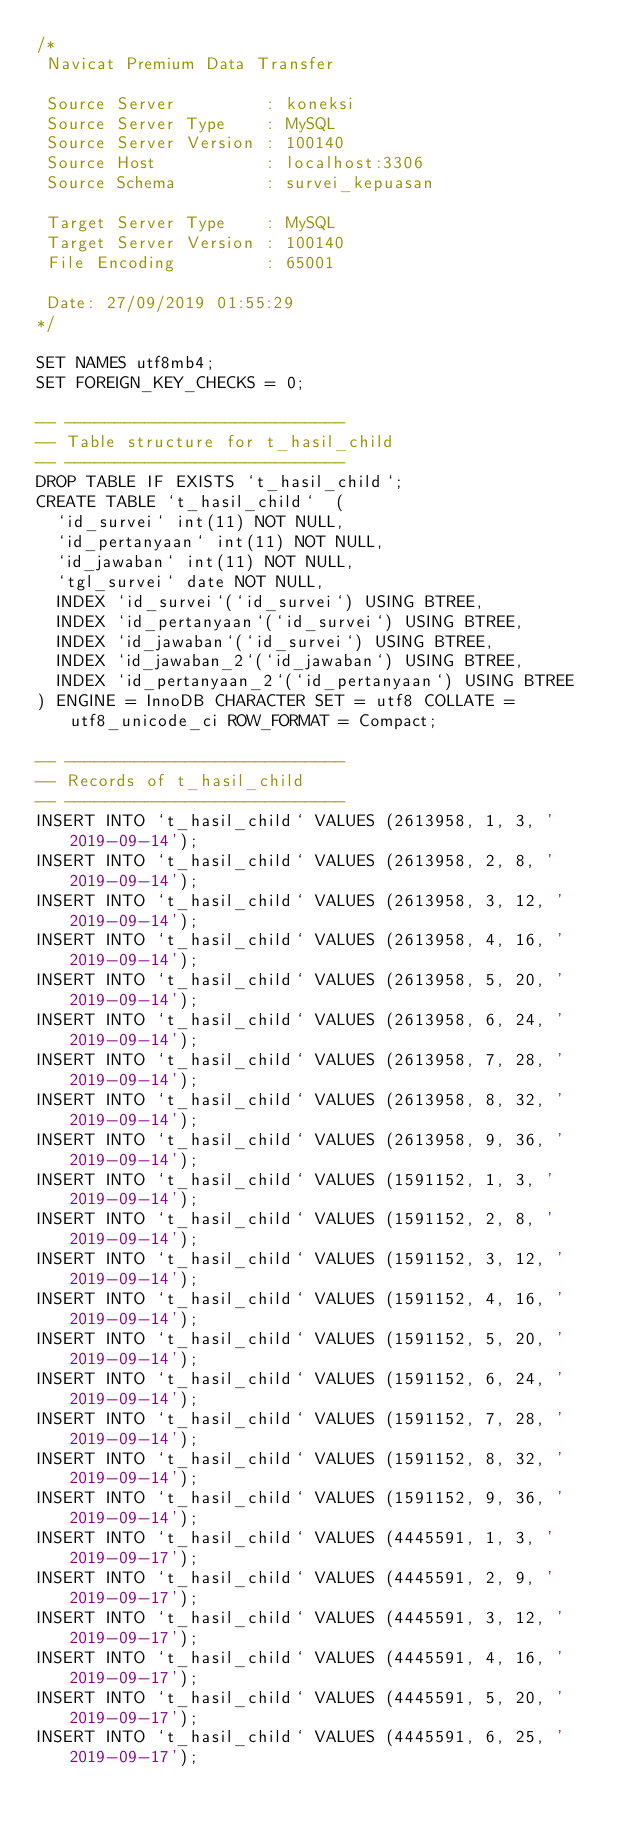<code> <loc_0><loc_0><loc_500><loc_500><_SQL_>/*
 Navicat Premium Data Transfer

 Source Server         : koneksi
 Source Server Type    : MySQL
 Source Server Version : 100140
 Source Host           : localhost:3306
 Source Schema         : survei_kepuasan

 Target Server Type    : MySQL
 Target Server Version : 100140
 File Encoding         : 65001

 Date: 27/09/2019 01:55:29
*/

SET NAMES utf8mb4;
SET FOREIGN_KEY_CHECKS = 0;

-- ----------------------------
-- Table structure for t_hasil_child
-- ----------------------------
DROP TABLE IF EXISTS `t_hasil_child`;
CREATE TABLE `t_hasil_child`  (
  `id_survei` int(11) NOT NULL,
  `id_pertanyaan` int(11) NOT NULL,
  `id_jawaban` int(11) NOT NULL,
  `tgl_survei` date NOT NULL,
  INDEX `id_survei`(`id_survei`) USING BTREE,
  INDEX `id_pertanyaan`(`id_survei`) USING BTREE,
  INDEX `id_jawaban`(`id_survei`) USING BTREE,
  INDEX `id_jawaban_2`(`id_jawaban`) USING BTREE,
  INDEX `id_pertanyaan_2`(`id_pertanyaan`) USING BTREE
) ENGINE = InnoDB CHARACTER SET = utf8 COLLATE = utf8_unicode_ci ROW_FORMAT = Compact;

-- ----------------------------
-- Records of t_hasil_child
-- ----------------------------
INSERT INTO `t_hasil_child` VALUES (2613958, 1, 3, '2019-09-14');
INSERT INTO `t_hasil_child` VALUES (2613958, 2, 8, '2019-09-14');
INSERT INTO `t_hasil_child` VALUES (2613958, 3, 12, '2019-09-14');
INSERT INTO `t_hasil_child` VALUES (2613958, 4, 16, '2019-09-14');
INSERT INTO `t_hasil_child` VALUES (2613958, 5, 20, '2019-09-14');
INSERT INTO `t_hasil_child` VALUES (2613958, 6, 24, '2019-09-14');
INSERT INTO `t_hasil_child` VALUES (2613958, 7, 28, '2019-09-14');
INSERT INTO `t_hasil_child` VALUES (2613958, 8, 32, '2019-09-14');
INSERT INTO `t_hasil_child` VALUES (2613958, 9, 36, '2019-09-14');
INSERT INTO `t_hasil_child` VALUES (1591152, 1, 3, '2019-09-14');
INSERT INTO `t_hasil_child` VALUES (1591152, 2, 8, '2019-09-14');
INSERT INTO `t_hasil_child` VALUES (1591152, 3, 12, '2019-09-14');
INSERT INTO `t_hasil_child` VALUES (1591152, 4, 16, '2019-09-14');
INSERT INTO `t_hasil_child` VALUES (1591152, 5, 20, '2019-09-14');
INSERT INTO `t_hasil_child` VALUES (1591152, 6, 24, '2019-09-14');
INSERT INTO `t_hasil_child` VALUES (1591152, 7, 28, '2019-09-14');
INSERT INTO `t_hasil_child` VALUES (1591152, 8, 32, '2019-09-14');
INSERT INTO `t_hasil_child` VALUES (1591152, 9, 36, '2019-09-14');
INSERT INTO `t_hasil_child` VALUES (4445591, 1, 3, '2019-09-17');
INSERT INTO `t_hasil_child` VALUES (4445591, 2, 9, '2019-09-17');
INSERT INTO `t_hasil_child` VALUES (4445591, 3, 12, '2019-09-17');
INSERT INTO `t_hasil_child` VALUES (4445591, 4, 16, '2019-09-17');
INSERT INTO `t_hasil_child` VALUES (4445591, 5, 20, '2019-09-17');
INSERT INTO `t_hasil_child` VALUES (4445591, 6, 25, '2019-09-17');</code> 